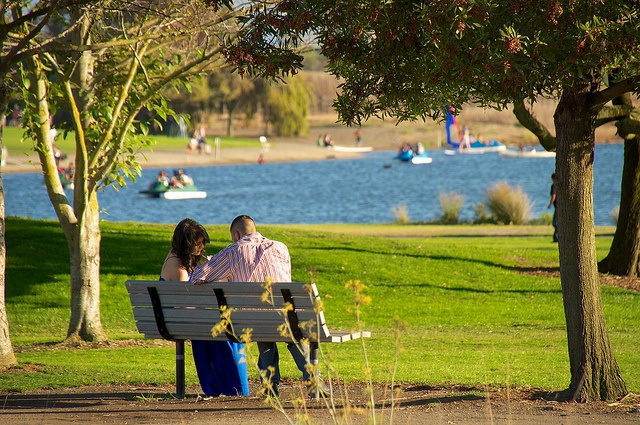Describe the objects in this image and their specific colors. I can see bench in black, gray, darkgreen, and tan tones, people in darkgreen, black, lightgray, gray, and lightpink tones, people in darkgreen, black, gray, and maroon tones, people in darkgreen, tan, and olive tones, and boat in darkgreen, ivory, teal, gray, and black tones in this image. 